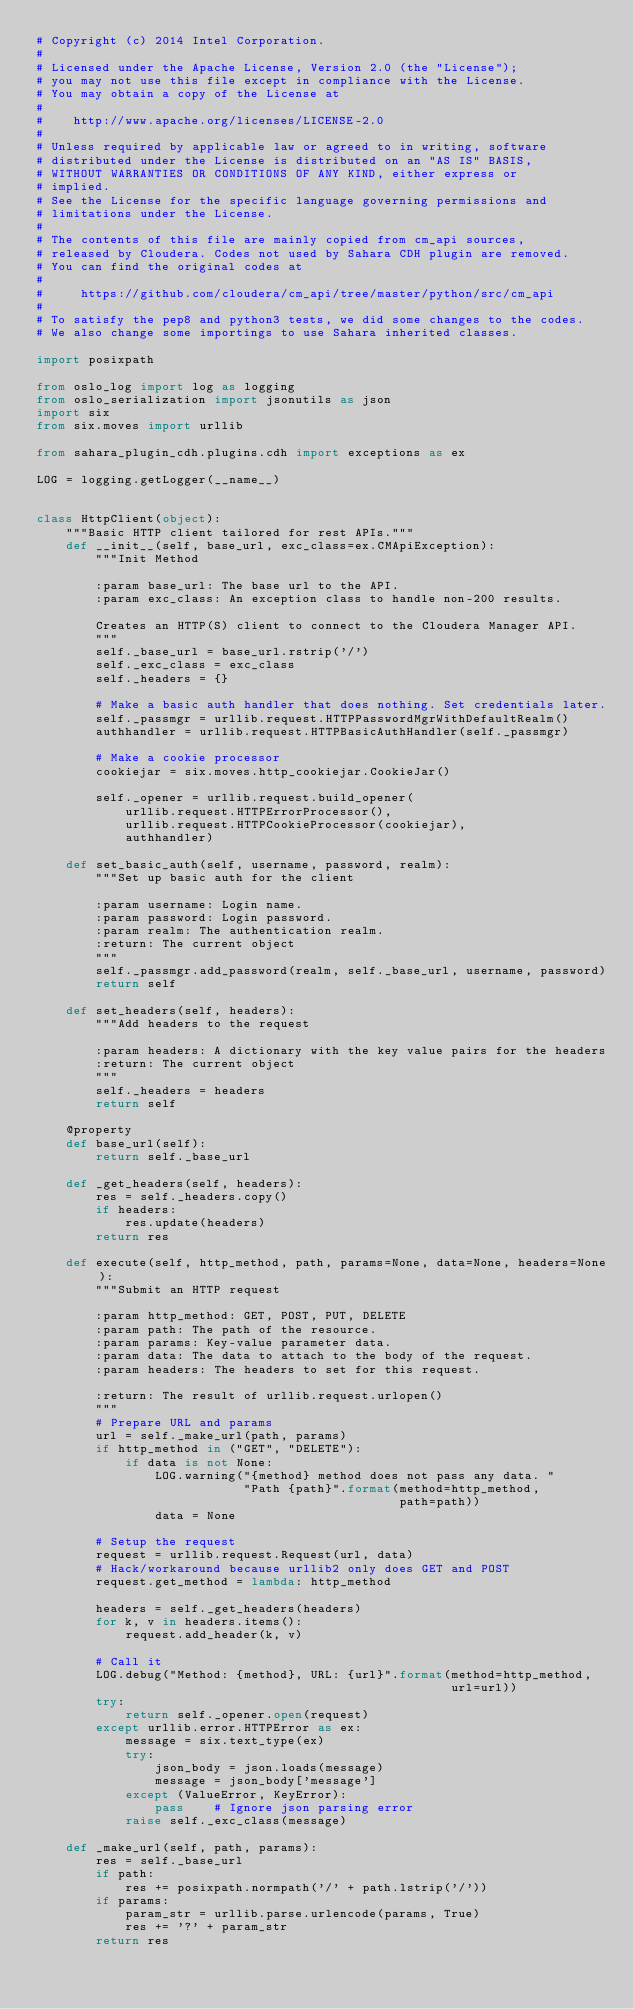<code> <loc_0><loc_0><loc_500><loc_500><_Python_># Copyright (c) 2014 Intel Corporation.
#
# Licensed under the Apache License, Version 2.0 (the "License");
# you may not use this file except in compliance with the License.
# You may obtain a copy of the License at
#
#    http://www.apache.org/licenses/LICENSE-2.0
#
# Unless required by applicable law or agreed to in writing, software
# distributed under the License is distributed on an "AS IS" BASIS,
# WITHOUT WARRANTIES OR CONDITIONS OF ANY KIND, either express or
# implied.
# See the License for the specific language governing permissions and
# limitations under the License.
#
# The contents of this file are mainly copied from cm_api sources,
# released by Cloudera. Codes not used by Sahara CDH plugin are removed.
# You can find the original codes at
#
#     https://github.com/cloudera/cm_api/tree/master/python/src/cm_api
#
# To satisfy the pep8 and python3 tests, we did some changes to the codes.
# We also change some importings to use Sahara inherited classes.

import posixpath

from oslo_log import log as logging
from oslo_serialization import jsonutils as json
import six
from six.moves import urllib

from sahara_plugin_cdh.plugins.cdh import exceptions as ex

LOG = logging.getLogger(__name__)


class HttpClient(object):
    """Basic HTTP client tailored for rest APIs."""
    def __init__(self, base_url, exc_class=ex.CMApiException):
        """Init Method

        :param base_url: The base url to the API.
        :param exc_class: An exception class to handle non-200 results.

        Creates an HTTP(S) client to connect to the Cloudera Manager API.
        """
        self._base_url = base_url.rstrip('/')
        self._exc_class = exc_class
        self._headers = {}

        # Make a basic auth handler that does nothing. Set credentials later.
        self._passmgr = urllib.request.HTTPPasswordMgrWithDefaultRealm()
        authhandler = urllib.request.HTTPBasicAuthHandler(self._passmgr)

        # Make a cookie processor
        cookiejar = six.moves.http_cookiejar.CookieJar()

        self._opener = urllib.request.build_opener(
            urllib.request.HTTPErrorProcessor(),
            urllib.request.HTTPCookieProcessor(cookiejar),
            authhandler)

    def set_basic_auth(self, username, password, realm):
        """Set up basic auth for the client

        :param username: Login name.
        :param password: Login password.
        :param realm: The authentication realm.
        :return: The current object
        """
        self._passmgr.add_password(realm, self._base_url, username, password)
        return self

    def set_headers(self, headers):
        """Add headers to the request

        :param headers: A dictionary with the key value pairs for the headers
        :return: The current object
        """
        self._headers = headers
        return self

    @property
    def base_url(self):
        return self._base_url

    def _get_headers(self, headers):
        res = self._headers.copy()
        if headers:
            res.update(headers)
        return res

    def execute(self, http_method, path, params=None, data=None, headers=None):
        """Submit an HTTP request

        :param http_method: GET, POST, PUT, DELETE
        :param path: The path of the resource.
        :param params: Key-value parameter data.
        :param data: The data to attach to the body of the request.
        :param headers: The headers to set for this request.

        :return: The result of urllib.request.urlopen()
        """
        # Prepare URL and params
        url = self._make_url(path, params)
        if http_method in ("GET", "DELETE"):
            if data is not None:
                LOG.warning("{method} method does not pass any data. "
                            "Path {path}".format(method=http_method,
                                                 path=path))
                data = None

        # Setup the request
        request = urllib.request.Request(url, data)
        # Hack/workaround because urllib2 only does GET and POST
        request.get_method = lambda: http_method

        headers = self._get_headers(headers)
        for k, v in headers.items():
            request.add_header(k, v)

        # Call it
        LOG.debug("Method: {method}, URL: {url}".format(method=http_method,
                                                        url=url))
        try:
            return self._opener.open(request)
        except urllib.error.HTTPError as ex:
            message = six.text_type(ex)
            try:
                json_body = json.loads(message)
                message = json_body['message']
            except (ValueError, KeyError):
                pass    # Ignore json parsing error
            raise self._exc_class(message)

    def _make_url(self, path, params):
        res = self._base_url
        if path:
            res += posixpath.normpath('/' + path.lstrip('/'))
        if params:
            param_str = urllib.parse.urlencode(params, True)
            res += '?' + param_str
        return res
</code> 